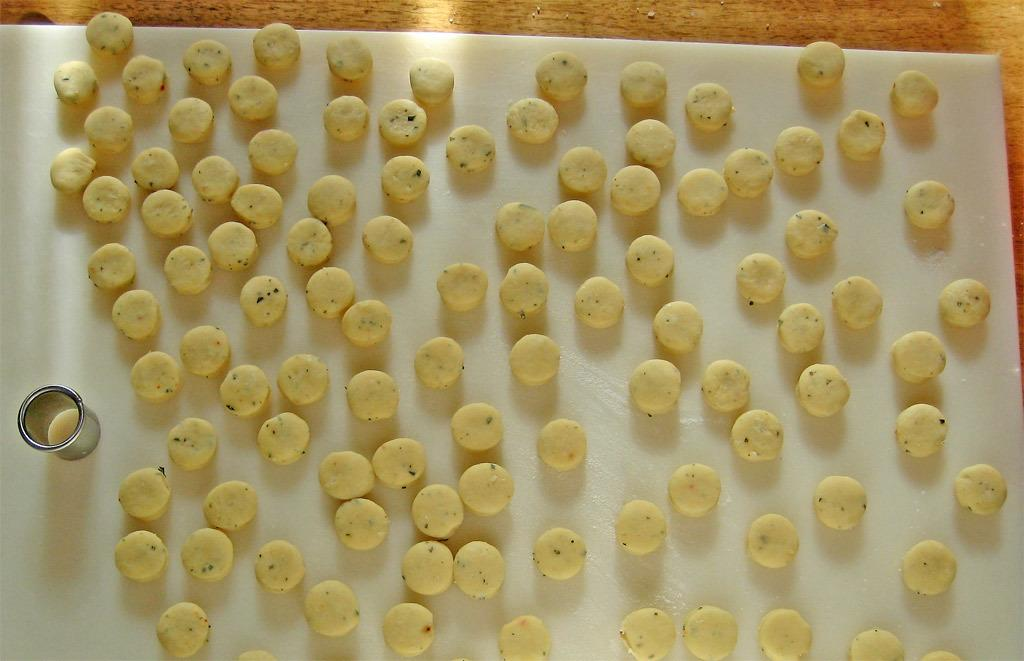What is the main subject of the image? The main subject of the image is food. What can be said about the surface on which the food is placed? The surface is white in color. Are there any other objects visible in the image besides the food? Yes, there is a glass in the image. How many flowers are on the table in the image? There are no flowers present in the image. What type of tail is visible on the food in the image? There is no tail visible on the food in the image. 